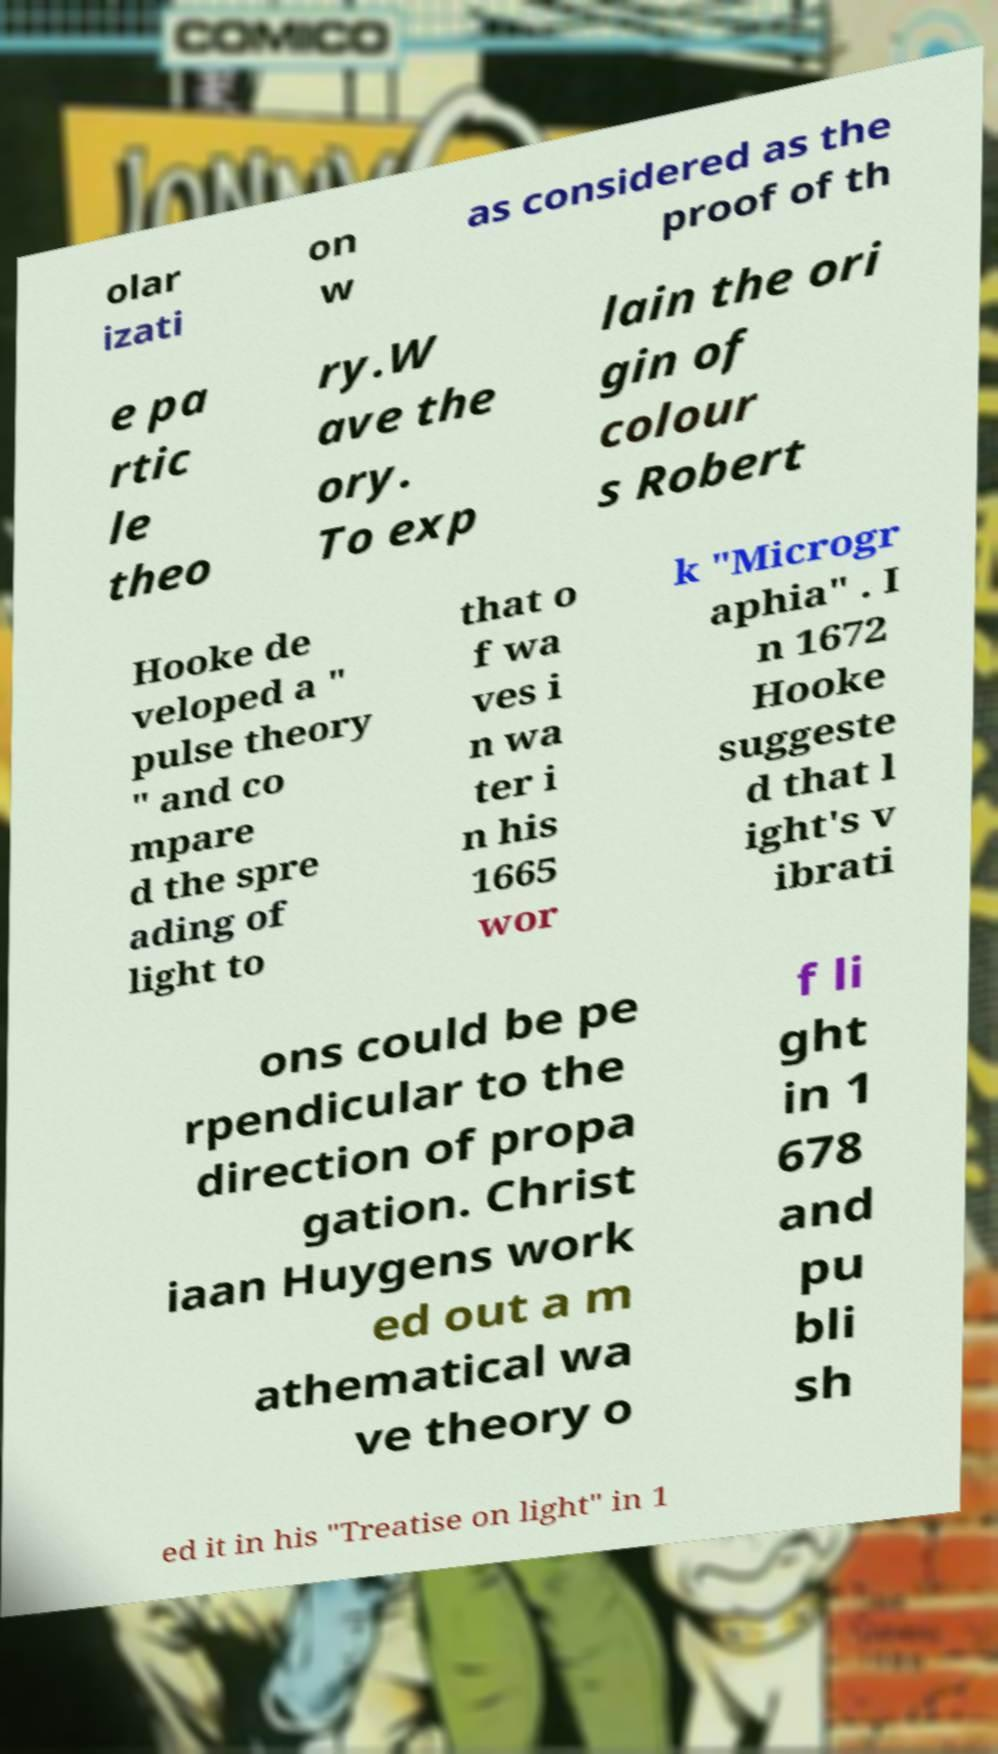Could you assist in decoding the text presented in this image and type it out clearly? olar izati on w as considered as the proof of th e pa rtic le theo ry.W ave the ory. To exp lain the ori gin of colour s Robert Hooke de veloped a " pulse theory " and co mpare d the spre ading of light to that o f wa ves i n wa ter i n his 1665 wor k "Microgr aphia" . I n 1672 Hooke suggeste d that l ight's v ibrati ons could be pe rpendicular to the direction of propa gation. Christ iaan Huygens work ed out a m athematical wa ve theory o f li ght in 1 678 and pu bli sh ed it in his "Treatise on light" in 1 